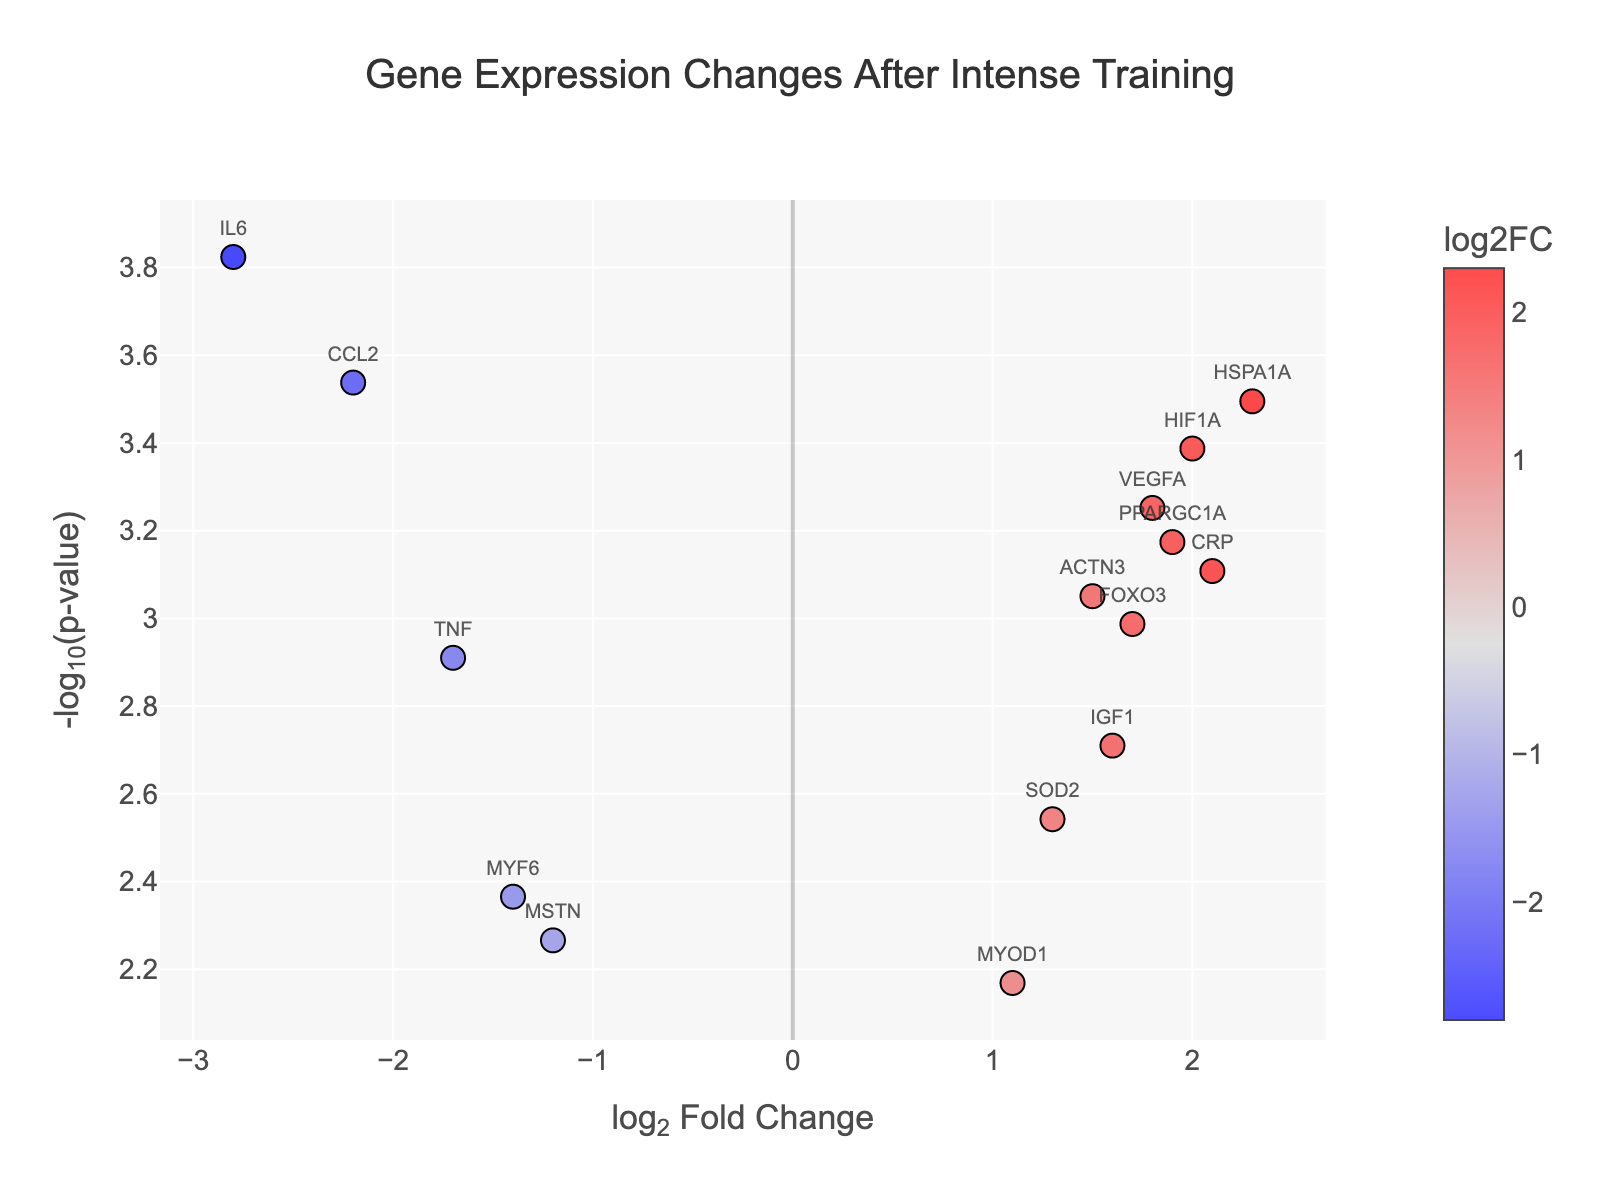What's the title of the figure? The title of the figure is displayed prominently at the top, indicating the main topic being visualized.
Answer: Gene Expression Changes After Intense Training How many genes have a negative log2 fold change? To find the number of genes with a negative log2 fold change, count the points to the left of the y-axis.
Answer: 4 Which gene has the highest log2 fold change? Look for the point farthest to the right on the x-axis and read the corresponding gene name.
Answer: HSPA1A Which gene has the lowest p-value? The lowest p-value corresponds to the highest point on the y-axis. Identify the gene associated with this point.
Answer: IL6 What color represents high log2 fold changes in the figure? The colors on the plot indicate different log2 fold changes. Based on the color scale, determine which color represents high log2 fold changes.
Answer: Red What is the range of -log10(p-value) in the figure? Identify the lowest and highest values of -log10(p-value) visible on the y-axis.
Answer: Approximately 2.2 to 3.8 How many genes have a p-value less than 0.001? Genes with a p-value less than 0.001 will have a -log10(p-value) greater than 3. Count the relevant points above this threshold.
Answer: 9 Which gene has the most significant down-regulation? Find the gene with the highest -log10(p-value) and a negative log2 fold change value.
Answer: IL6 Compare the log2 fold change between PPARGC1A and MSTN. Which gene has a higher value? Locate the points for PPARGC1A and MSTN on the x-axis and compare their log2 fold change values.
Answer: PPARGC1A Which genes are highlighted with text on the plot? Look at the plot and note which gene names are displayed next to the data points.
Answer: IL6, ACTN3, HSPA1A, PPARGC1A, TNF, MSTN, CRP, IGF1, VEGFA, SOD2, MYF6, HIF1A, MYOD1, CCL2, FOXO3 